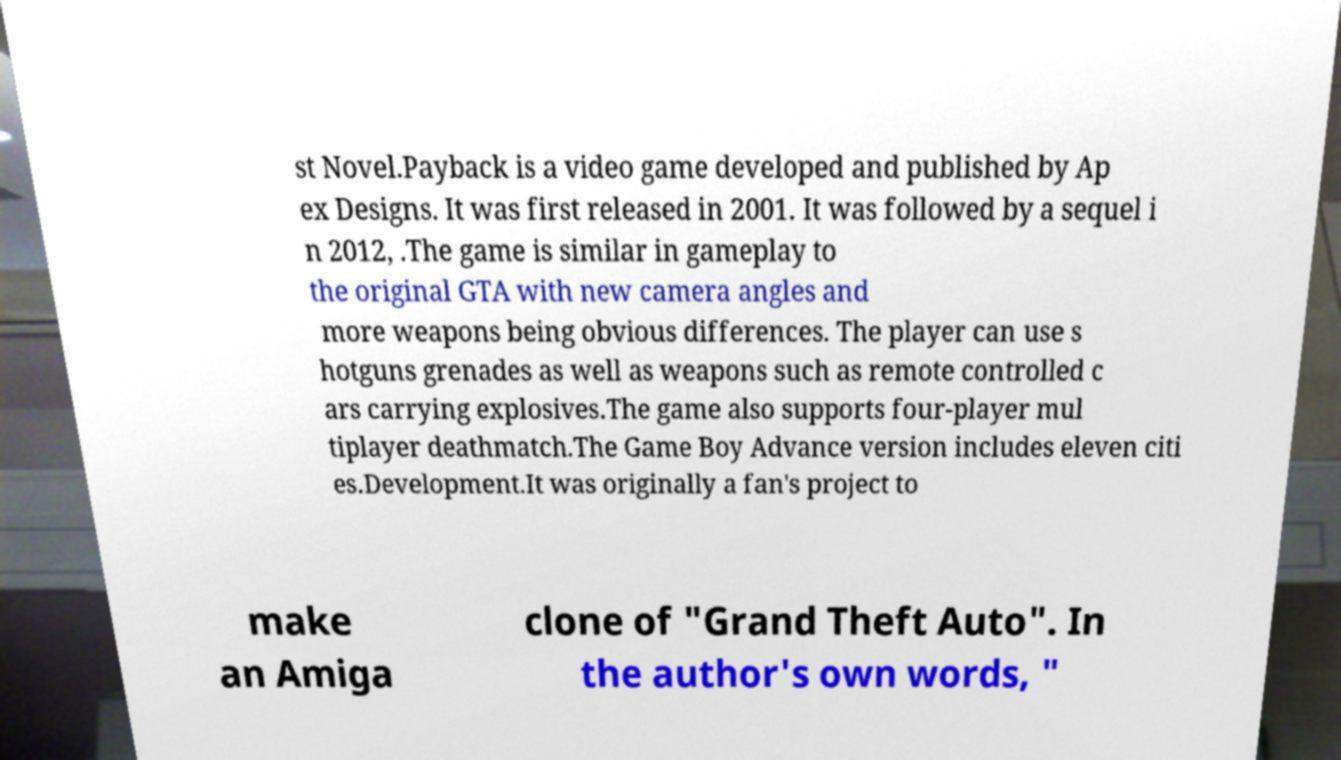What messages or text are displayed in this image? I need them in a readable, typed format. st Novel.Payback is a video game developed and published by Ap ex Designs. It was first released in 2001. It was followed by a sequel i n 2012, .The game is similar in gameplay to the original GTA with new camera angles and more weapons being obvious differences. The player can use s hotguns grenades as well as weapons such as remote controlled c ars carrying explosives.The game also supports four-player mul tiplayer deathmatch.The Game Boy Advance version includes eleven citi es.Development.It was originally a fan's project to make an Amiga clone of "Grand Theft Auto". In the author's own words, " 